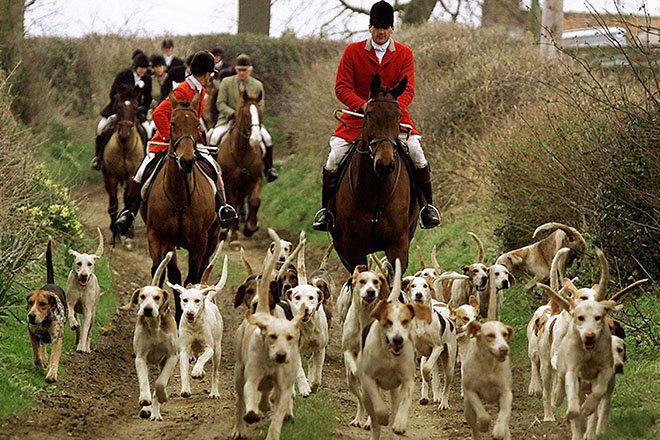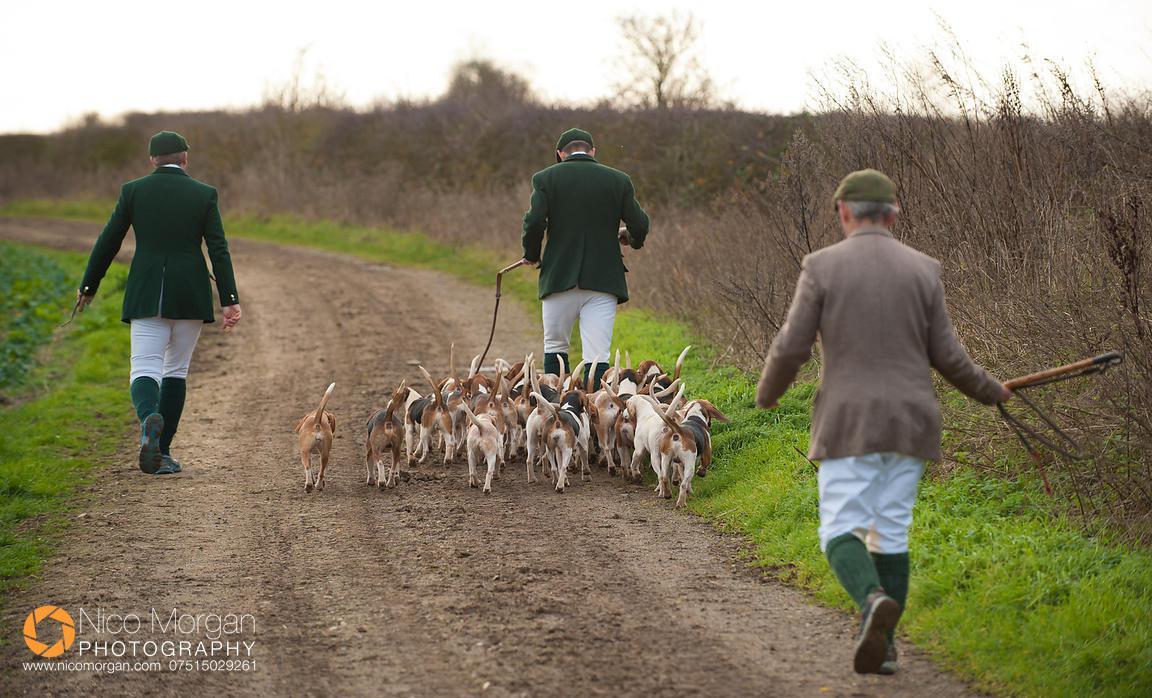The first image is the image on the left, the second image is the image on the right. Considering the images on both sides, is "There is no more than two people in both images." valid? Answer yes or no. No. The first image is the image on the left, the second image is the image on the right. Given the left and right images, does the statement "at least one image shows no sky line" hold true? Answer yes or no. No. 